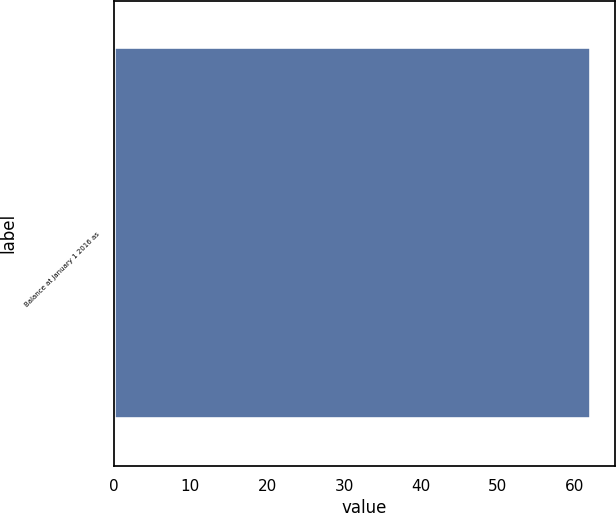Convert chart to OTSL. <chart><loc_0><loc_0><loc_500><loc_500><bar_chart><fcel>Balance at January 1 2016 as<nl><fcel>62.1<nl></chart> 